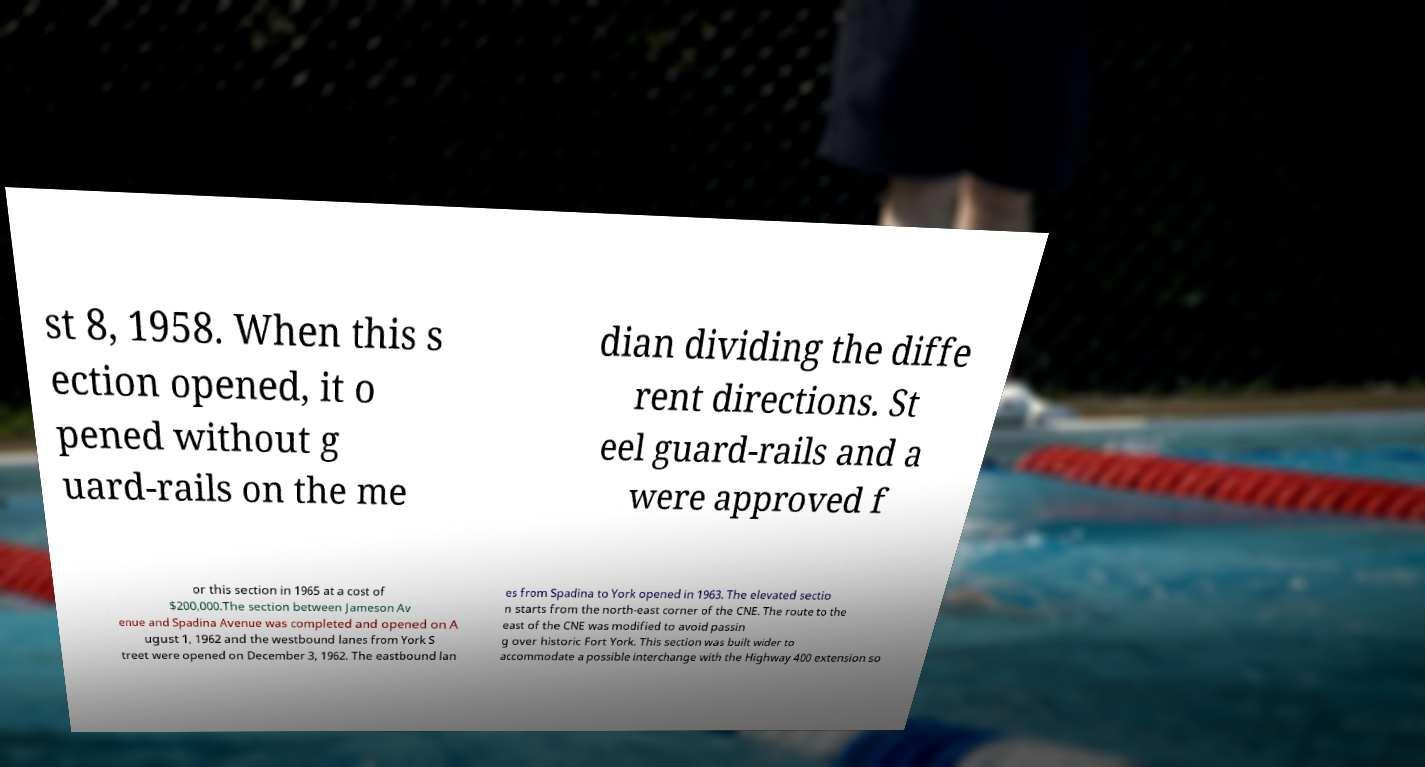For documentation purposes, I need the text within this image transcribed. Could you provide that? st 8, 1958. When this s ection opened, it o pened without g uard-rails on the me dian dividing the diffe rent directions. St eel guard-rails and a were approved f or this section in 1965 at a cost of $200,000.The section between Jameson Av enue and Spadina Avenue was completed and opened on A ugust 1, 1962 and the westbound lanes from York S treet were opened on December 3, 1962. The eastbound lan es from Spadina to York opened in 1963. The elevated sectio n starts from the north-east corner of the CNE. The route to the east of the CNE was modified to avoid passin g over historic Fort York. This section was built wider to accommodate a possible interchange with the Highway 400 extension so 